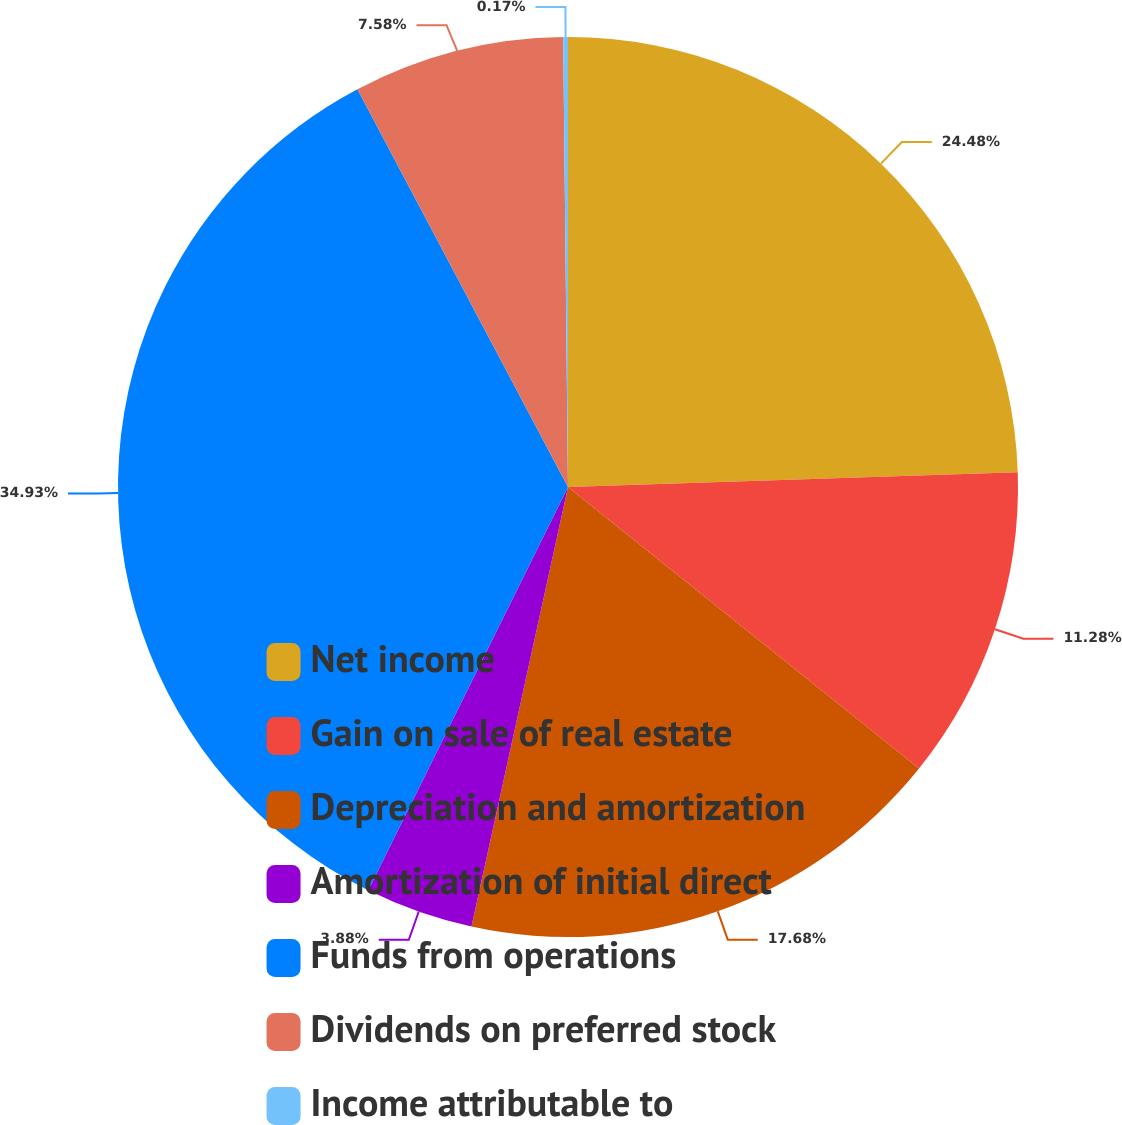Convert chart. <chart><loc_0><loc_0><loc_500><loc_500><pie_chart><fcel>Net income<fcel>Gain on sale of real estate<fcel>Depreciation and amortization<fcel>Amortization of initial direct<fcel>Funds from operations<fcel>Dividends on preferred stock<fcel>Income attributable to<nl><fcel>24.48%<fcel>11.28%<fcel>17.68%<fcel>3.88%<fcel>34.93%<fcel>7.58%<fcel>0.17%<nl></chart> 